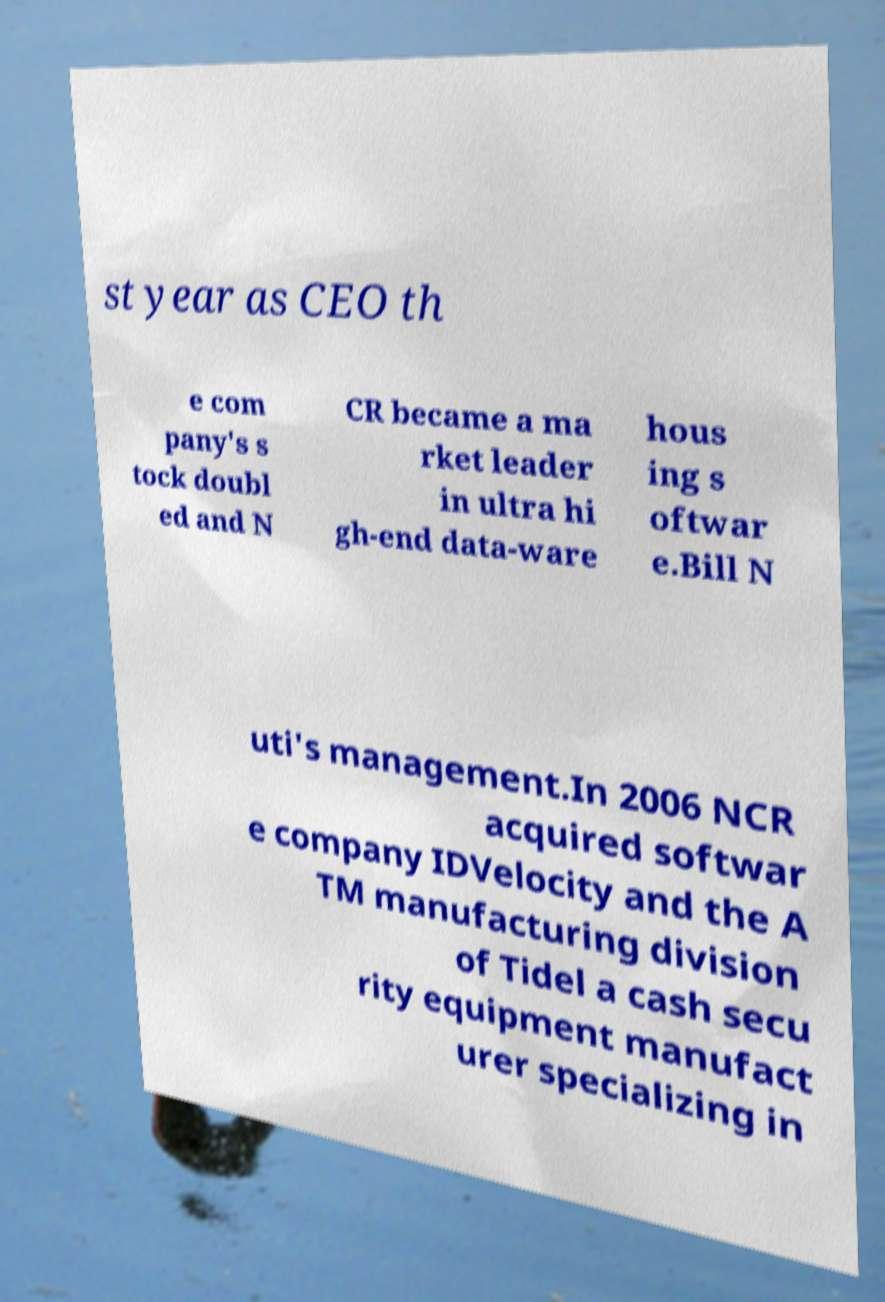Could you extract and type out the text from this image? st year as CEO th e com pany's s tock doubl ed and N CR became a ma rket leader in ultra hi gh-end data-ware hous ing s oftwar e.Bill N uti's management.In 2006 NCR acquired softwar e company IDVelocity and the A TM manufacturing division of Tidel a cash secu rity equipment manufact urer specializing in 